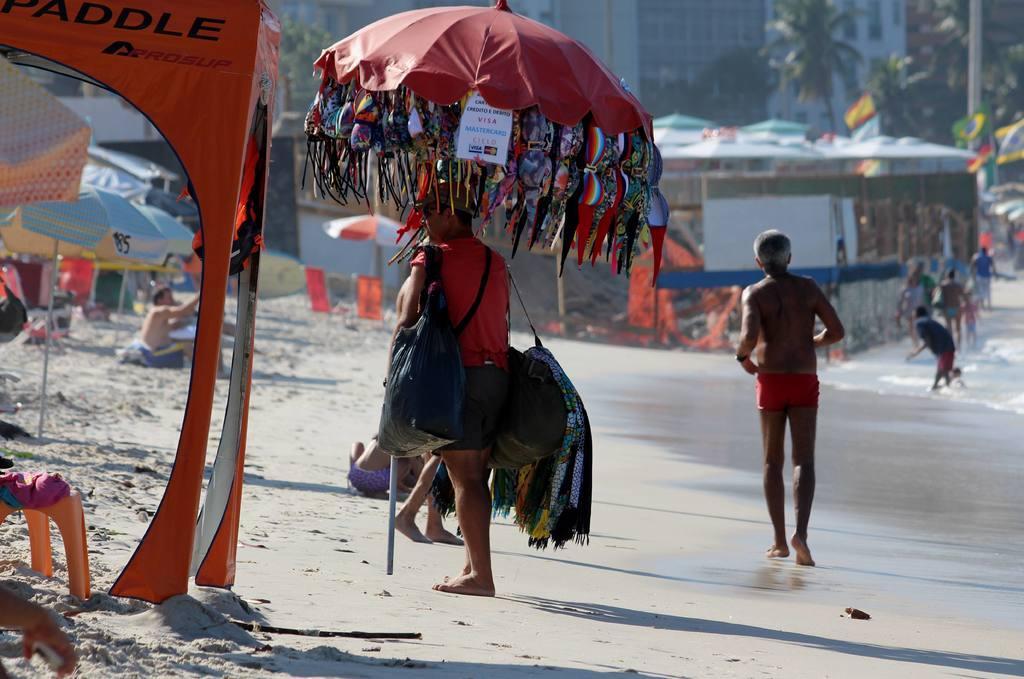Describe this image in one or two sentences. In this picture I can see buildings and trees and few people walking and few people are seated on the ground and I can see a man holding a umbrella and he wore few bags and few clothes hanging to the umbrella and I can see few umbrellas on the seashore and I can see few flags and water. 